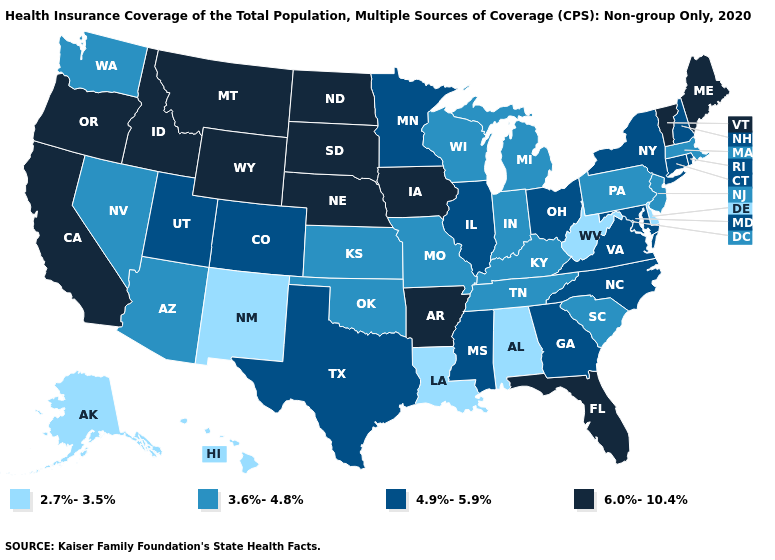Does Vermont have the lowest value in the Northeast?
Quick response, please. No. What is the lowest value in states that border Delaware?
Be succinct. 3.6%-4.8%. Does Louisiana have the lowest value in the South?
Quick response, please. Yes. What is the value of South Carolina?
Concise answer only. 3.6%-4.8%. What is the value of Alaska?
Answer briefly. 2.7%-3.5%. What is the value of Arkansas?
Give a very brief answer. 6.0%-10.4%. Among the states that border Connecticut , does Rhode Island have the highest value?
Answer briefly. Yes. What is the value of Oregon?
Short answer required. 6.0%-10.4%. Name the states that have a value in the range 3.6%-4.8%?
Quick response, please. Arizona, Indiana, Kansas, Kentucky, Massachusetts, Michigan, Missouri, Nevada, New Jersey, Oklahoma, Pennsylvania, South Carolina, Tennessee, Washington, Wisconsin. What is the lowest value in the West?
Keep it brief. 2.7%-3.5%. Does South Dakota have the highest value in the MidWest?
Be succinct. Yes. Does Kentucky have a lower value than Massachusetts?
Quick response, please. No. What is the value of Louisiana?
Write a very short answer. 2.7%-3.5%. Does the first symbol in the legend represent the smallest category?
Be succinct. Yes. What is the value of New Hampshire?
Short answer required. 4.9%-5.9%. 